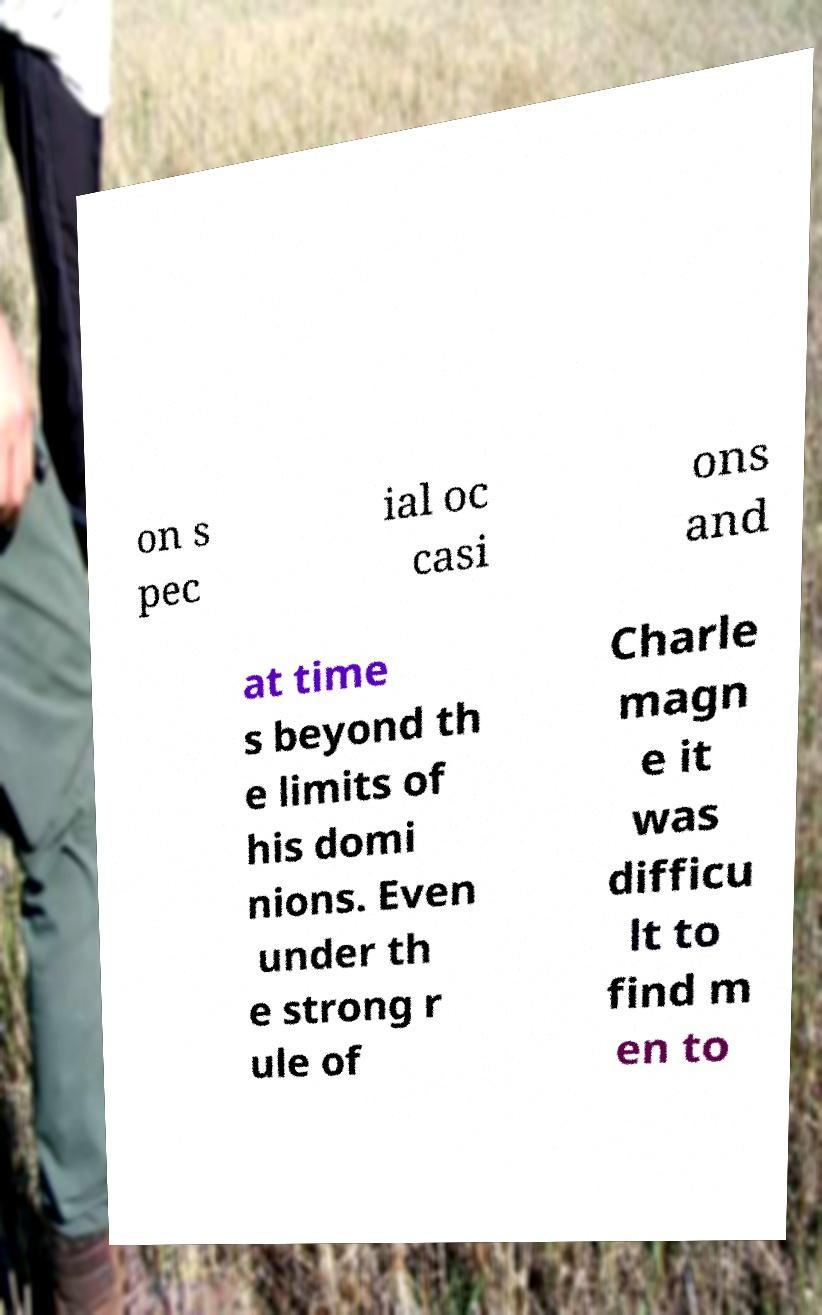There's text embedded in this image that I need extracted. Can you transcribe it verbatim? on s pec ial oc casi ons and at time s beyond th e limits of his domi nions. Even under th e strong r ule of Charle magn e it was difficu lt to find m en to 